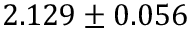<formula> <loc_0><loc_0><loc_500><loc_500>2 . 1 2 9 \pm 0 . 0 5 6</formula> 